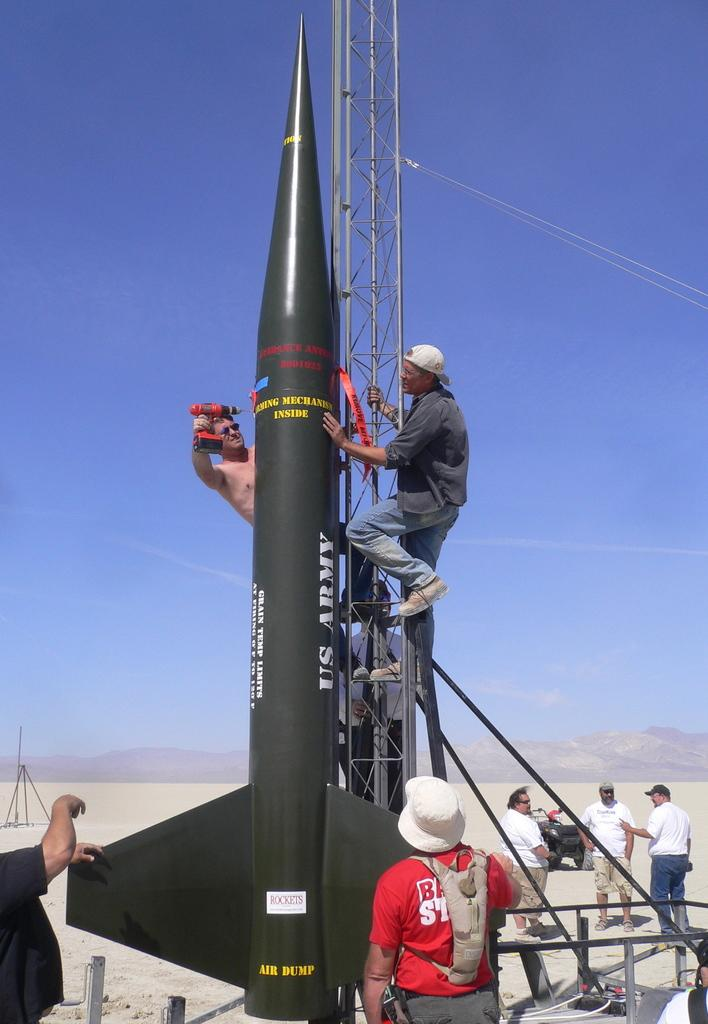What is the main subject of the image? The main subject of the image is a rocket. What color is the rocket? The rocket is gray in color. Are there any people in the image? Yes, there are people standing in the image. What can be seen in the background of the image? Mountains are visible in the background of the image. What is the color of the sky in the image? The sky is blue in color. What is the purpose of the canvas in the image? There is no canvas present in the image; it features a rocket, people, mountains, and a blue sky. 